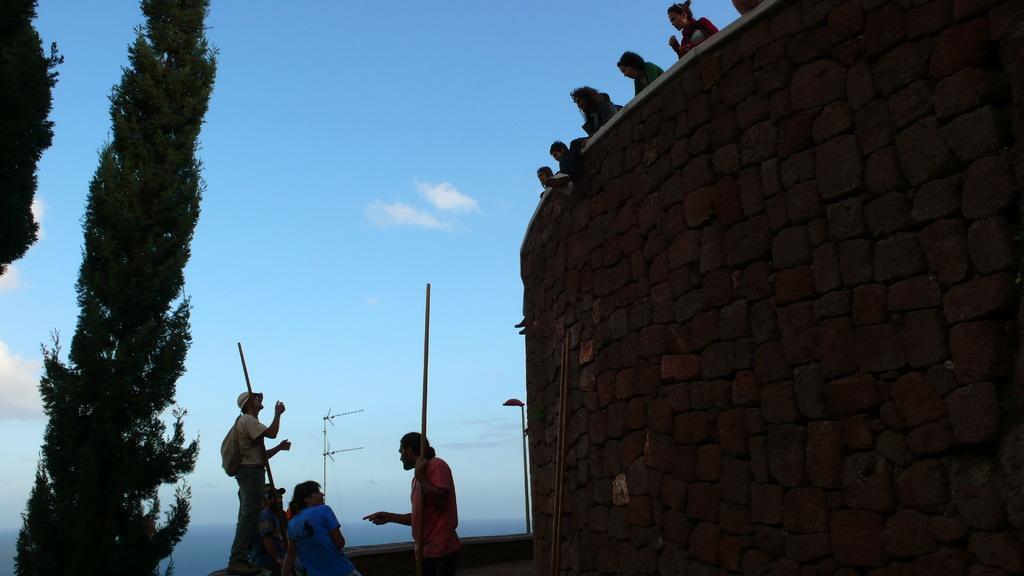Describe this image in one or two sentences. In the picture I can see the rock wall on the right side and I can see a few persons on the side of the wall on the top right side. I can see a few people at the bottom of the picture and I can see two of them holding the wooden stick in their hands. There are trees on the left side. There are clouds in the sky. 